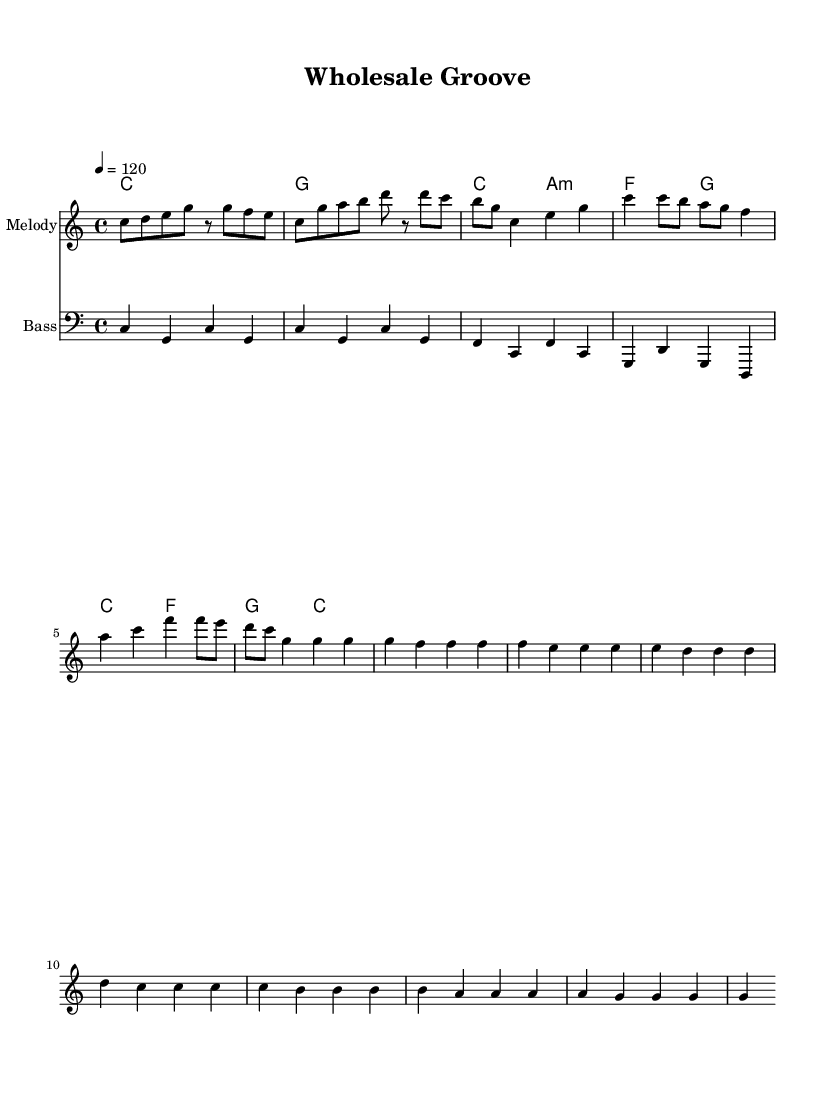What is the key signature of this music? The key signature is C major, which has no sharps or flats indicated in the music section.
Answer: C major What is the time signature of this music? The time signature is 4/4, which can be found at the beginning of the score indicating four beats per measure.
Answer: 4/4 What is the tempo marking of this music? The tempo marking is 120 beats per minute, specifically indicated in the score using the tempo instruction "4 = 120".
Answer: 120 How many measures are in the Chorus section? The Chorus consists of four measures, which can be counted in the music section where the melody is presented.
Answer: 4 Which chord follows the C major chord in the verse? In the verse, the chord progression shows that after the C major chord, it moves to the A minor chord, as indicated in the harmonies section.
Answer: A minor What is the bass clef for the first note? The first note in the bass line is C, which can be seen at the beginning of the bass staff.
Answer: C Identify the style of this music piece. The piece embodies the funk style, characterized by its upbeat rhythm and groove, evident in the tempo and rhythmic patterns throughout the score.
Answer: Funk 